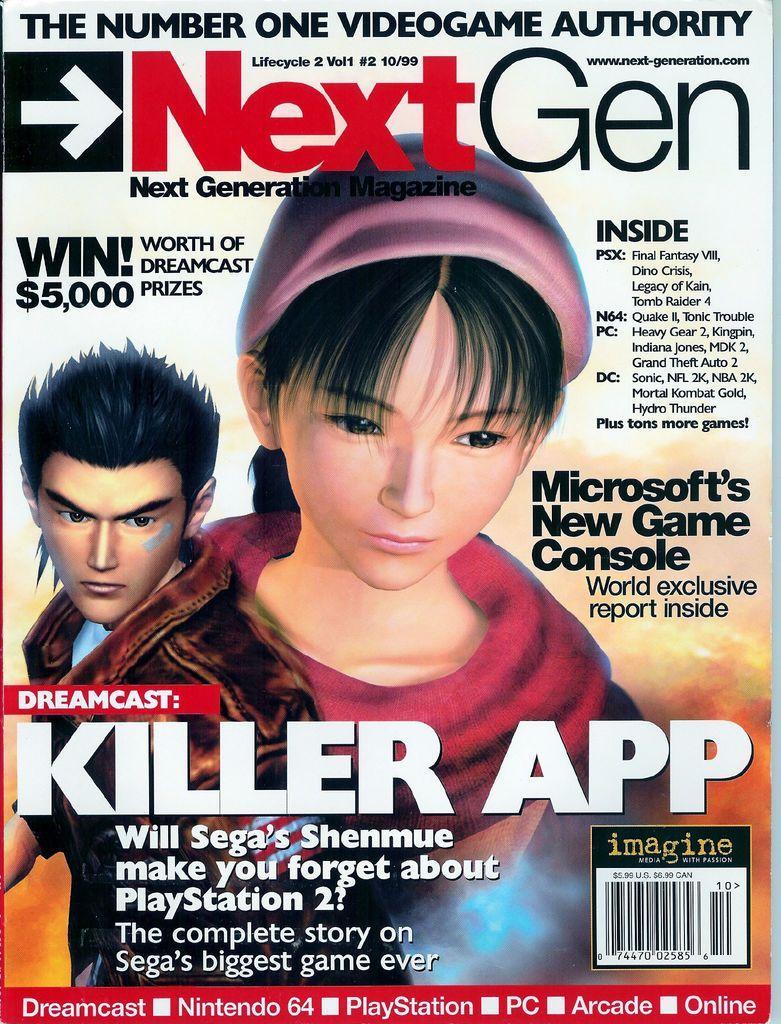Describe this image in one or two sentences. Here we can see a poster. On this poster we can see animated people and text written on it. 